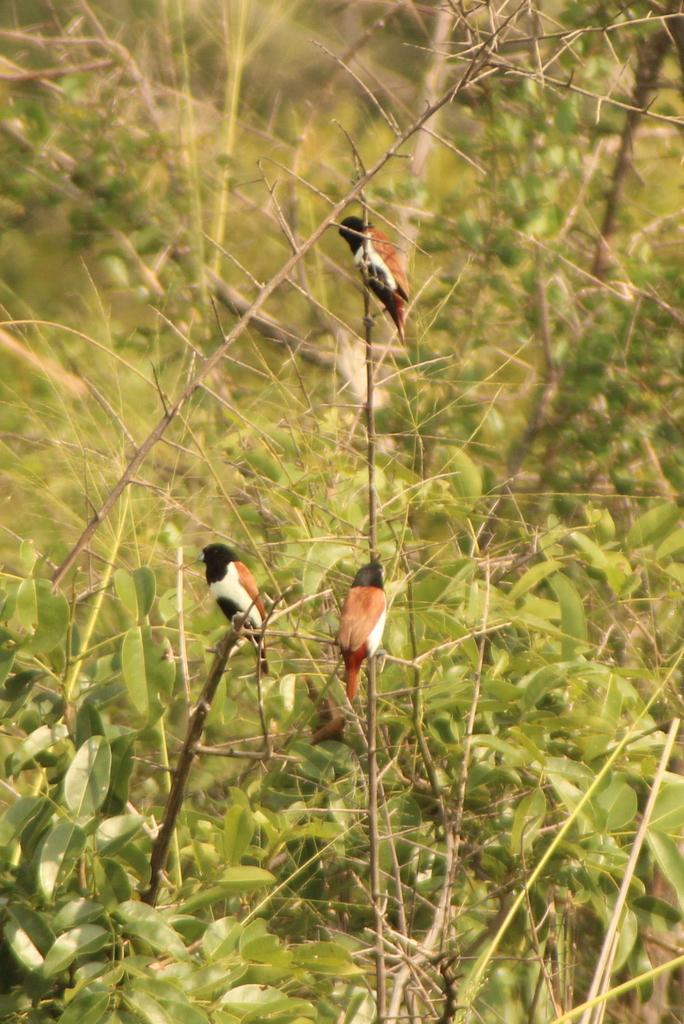How many birds are visible in the image? There are three birds in the image. Where are the birds located? The birds are on branches in the image. What else can be seen in the image besides the birds? There are leaves visible in the image. Can you describe the background of the image? The background appears blurry in the image. Is there any quicksand visible in the image? No, there is no quicksand present in the image. Are the birds engaged in an argument in the image? No, the birds are not engaged in an argument in the image; they are simply perched on branches. 